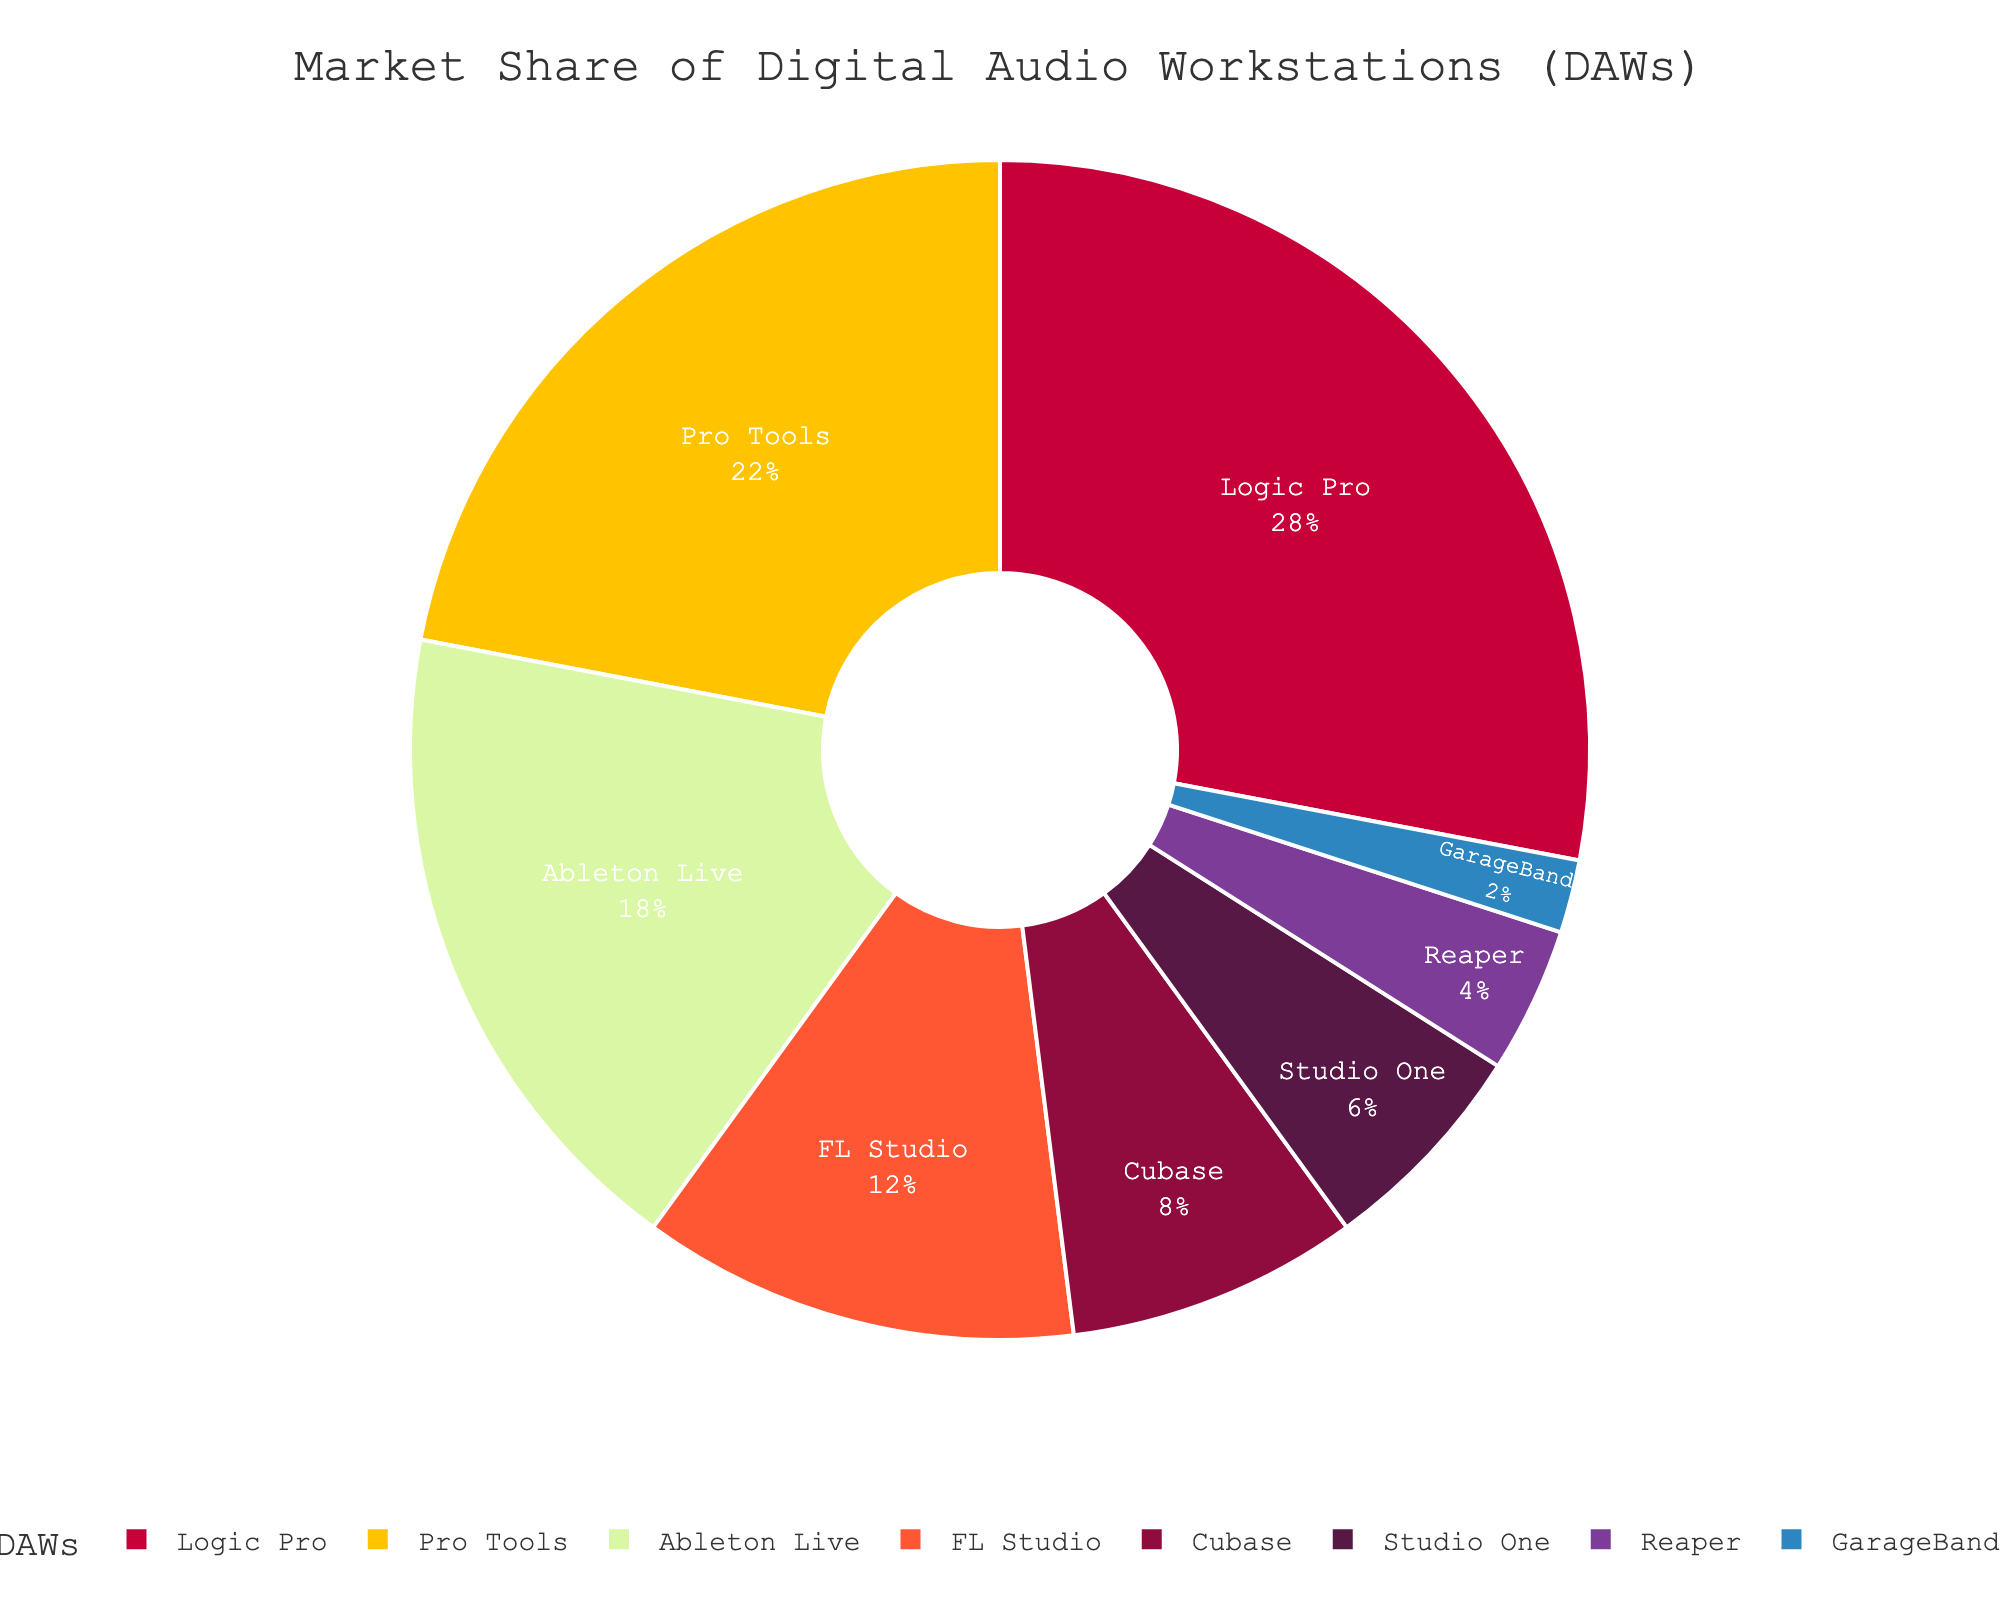Which DAW has the largest market share? Identify the DAW with the highest percentage value in the pie chart. Logic Pro at 28% is the highest.
Answer: Logic Pro What is the total market share of FL Studio and Reaper combined? Add the market shares of FL Studio and Reaper. 12% + 4% = 16%.
Answer: 16% Which DAW has a market share exactly half of Ableton Live’s? Ableton Live has an 18% market share. Half of 18% is 9%. The DAW closest to this value is Cubase with an 8% market share.
Answer: Cubase Which DAW has a higher market share, Studio One or GarageBand, and by how much? Subtract GarageBand’s market share (2%) from Studio One’s market share (6%). 6% - 2% = 4%.
Answer: Studio One, by 4% What is the difference between the market shares of Pro Tools and Cubase? Subtract Cubase’s market share from Pro Tools’ market share. 22% - 8% = 14%.
Answer: 14% What is the market share of the least popular DAW? Identify the DAW with the smallest percentage in the pie chart. GarageBand has the smallest share at 2%.
Answer: 2% What is the average market share of Logic Pro, Pro Tools, and Ableton Live? Add their market shares and divide by 3. (28% + 22% + 18%) / 3 = 22.67%.
Answer: 22.67% What is the cumulative market share of the DAWs other than Logic Pro and Pro Tools? Subtract the combined market share of Logic Pro and Pro Tools from 100%. 100% - (28% + 22%) = 50%.
Answer: 50% Which color represents Cubase in the pie chart? The DAW Cubase is visually identified by its specific color which is the fifth segment in the custom color scheme used. Cubase is purple.
Answer: Purple Compare the market shares of FL Studio and Reaper; which one is twice as large as the other? FL Studio has 12%, and Reaper has 4%. 12% is three times the 4%, not twice. Instead, Studio One at 6% is approximately 1.5 times Reaper’s 4%.
Answer: None 